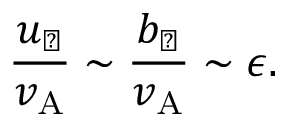<formula> <loc_0><loc_0><loc_500><loc_500>\frac { u _ { \perp } } { v _ { A } } \sim \frac { b _ { \perp } } { v _ { A } } \sim \epsilon .</formula> 